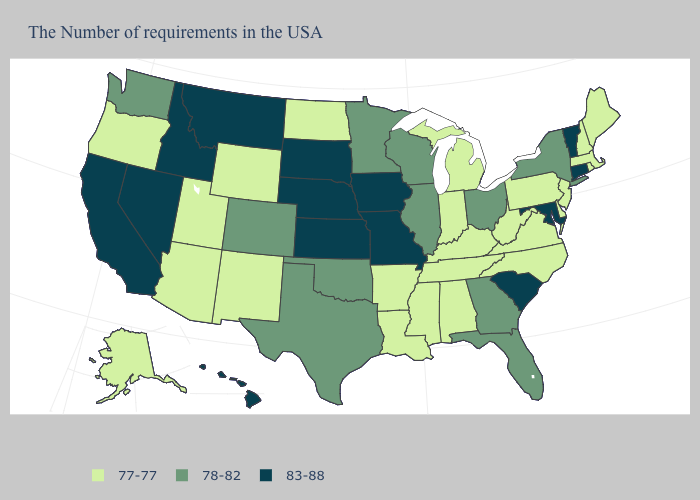Does California have the highest value in the West?
Give a very brief answer. Yes. What is the highest value in the USA?
Keep it brief. 83-88. Name the states that have a value in the range 77-77?
Keep it brief. Maine, Massachusetts, Rhode Island, New Hampshire, New Jersey, Delaware, Pennsylvania, Virginia, North Carolina, West Virginia, Michigan, Kentucky, Indiana, Alabama, Tennessee, Mississippi, Louisiana, Arkansas, North Dakota, Wyoming, New Mexico, Utah, Arizona, Oregon, Alaska. Does Maine have the lowest value in the USA?
Keep it brief. Yes. What is the value of Maine?
Write a very short answer. 77-77. Does the first symbol in the legend represent the smallest category?
Answer briefly. Yes. Name the states that have a value in the range 77-77?
Concise answer only. Maine, Massachusetts, Rhode Island, New Hampshire, New Jersey, Delaware, Pennsylvania, Virginia, North Carolina, West Virginia, Michigan, Kentucky, Indiana, Alabama, Tennessee, Mississippi, Louisiana, Arkansas, North Dakota, Wyoming, New Mexico, Utah, Arizona, Oregon, Alaska. Among the states that border Alabama , which have the highest value?
Give a very brief answer. Florida, Georgia. Does New Jersey have the highest value in the Northeast?
Answer briefly. No. How many symbols are there in the legend?
Concise answer only. 3. Name the states that have a value in the range 83-88?
Keep it brief. Vermont, Connecticut, Maryland, South Carolina, Missouri, Iowa, Kansas, Nebraska, South Dakota, Montana, Idaho, Nevada, California, Hawaii. What is the highest value in states that border Mississippi?
Quick response, please. 77-77. Does the map have missing data?
Answer briefly. No. Does Kansas have the highest value in the MidWest?
Short answer required. Yes. Name the states that have a value in the range 77-77?
Be succinct. Maine, Massachusetts, Rhode Island, New Hampshire, New Jersey, Delaware, Pennsylvania, Virginia, North Carolina, West Virginia, Michigan, Kentucky, Indiana, Alabama, Tennessee, Mississippi, Louisiana, Arkansas, North Dakota, Wyoming, New Mexico, Utah, Arizona, Oregon, Alaska. 